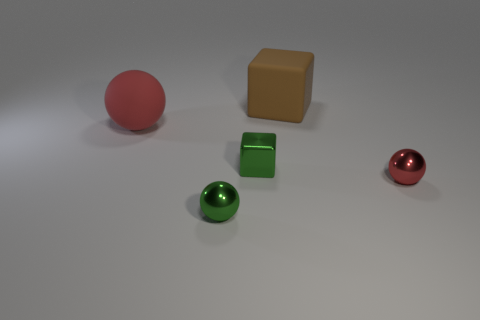Are there fewer big cubes that are to the left of the brown block than red things that are behind the metal block?
Ensure brevity in your answer.  Yes. How many other blocks have the same color as the small cube?
Your answer should be compact. 0. What material is the small ball that is the same color as the large matte ball?
Your response must be concise. Metal. What number of balls are both on the left side of the tiny red ball and behind the green sphere?
Your answer should be compact. 1. There is a ball that is behind the green cube in front of the matte cube; what is its material?
Provide a short and direct response. Rubber. Are there any things made of the same material as the tiny green sphere?
Your response must be concise. Yes. What is the material of the red ball that is the same size as the green block?
Give a very brief answer. Metal. How big is the block that is in front of the big rubber object left of the large thing that is on the right side of the green sphere?
Keep it short and to the point. Small. There is a red thing that is right of the small green metal sphere; are there any things in front of it?
Your answer should be very brief. Yes. Do the big red rubber object and the rubber object to the right of the large red ball have the same shape?
Ensure brevity in your answer.  No. 